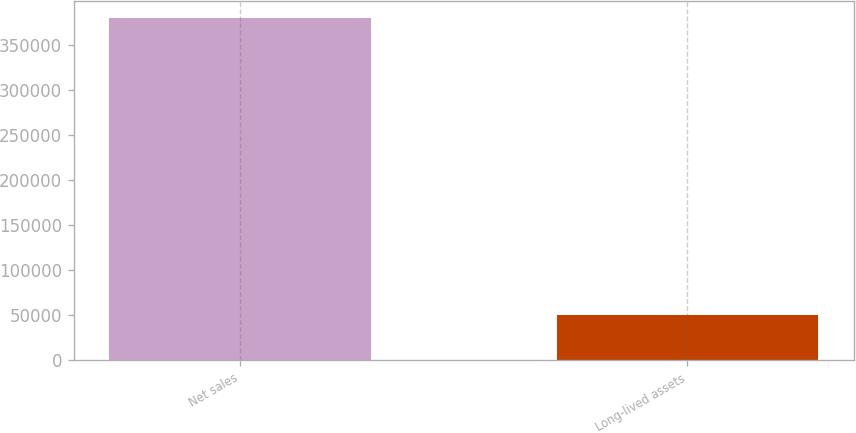<chart> <loc_0><loc_0><loc_500><loc_500><bar_chart><fcel>Net sales<fcel>Long-lived assets<nl><fcel>379820<fcel>50077<nl></chart> 